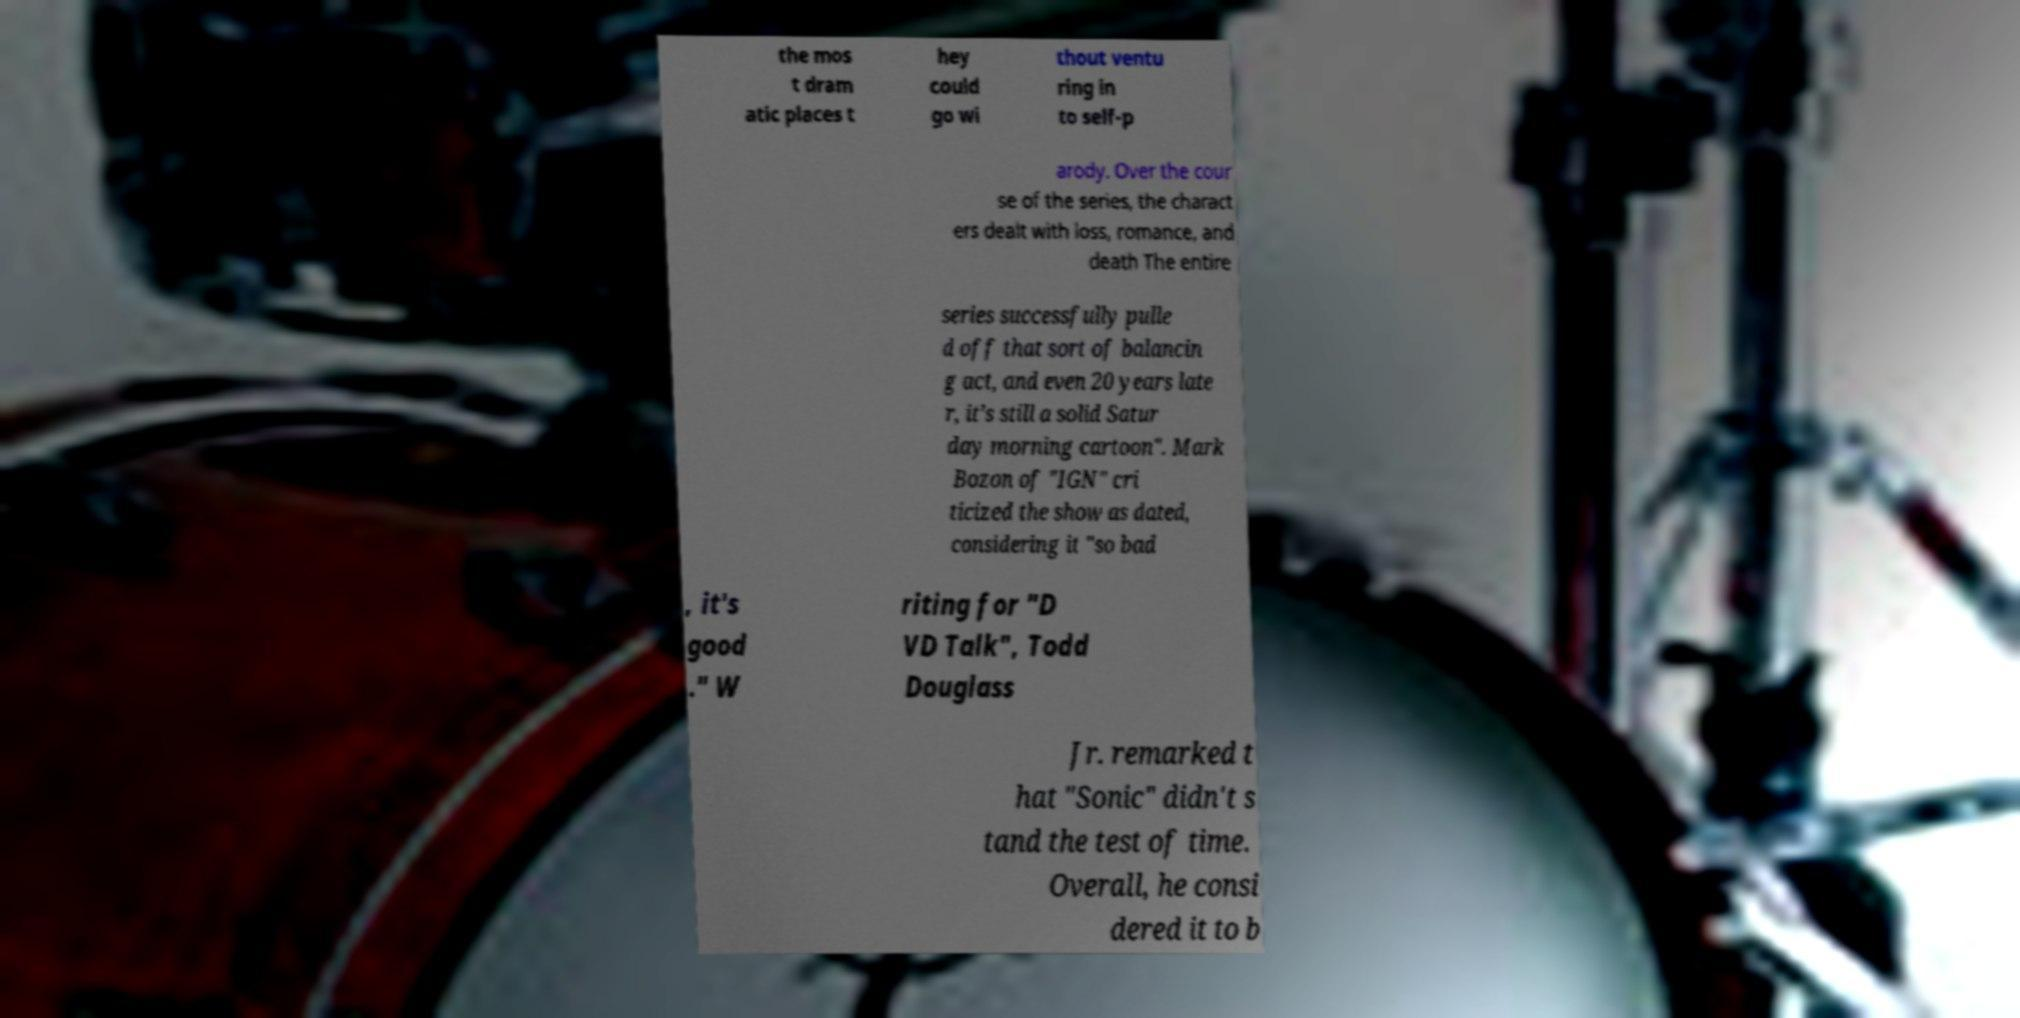Please identify and transcribe the text found in this image. the mos t dram atic places t hey could go wi thout ventu ring in to self-p arody. Over the cour se of the series, the charact ers dealt with loss, romance, and death The entire series successfully pulle d off that sort of balancin g act, and even 20 years late r, it’s still a solid Satur day morning cartoon". Mark Bozon of "IGN" cri ticized the show as dated, considering it "so bad , it's good ." W riting for "D VD Talk", Todd Douglass Jr. remarked t hat "Sonic" didn't s tand the test of time. Overall, he consi dered it to b 